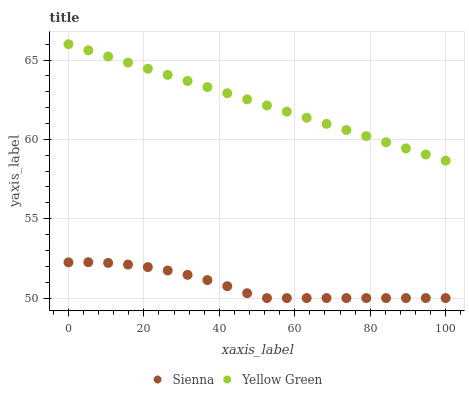Does Sienna have the minimum area under the curve?
Answer yes or no. Yes. Does Yellow Green have the maximum area under the curve?
Answer yes or no. Yes. Does Yellow Green have the minimum area under the curve?
Answer yes or no. No. Is Yellow Green the smoothest?
Answer yes or no. Yes. Is Sienna the roughest?
Answer yes or no. Yes. Is Yellow Green the roughest?
Answer yes or no. No. Does Sienna have the lowest value?
Answer yes or no. Yes. Does Yellow Green have the lowest value?
Answer yes or no. No. Does Yellow Green have the highest value?
Answer yes or no. Yes. Is Sienna less than Yellow Green?
Answer yes or no. Yes. Is Yellow Green greater than Sienna?
Answer yes or no. Yes. Does Sienna intersect Yellow Green?
Answer yes or no. No. 